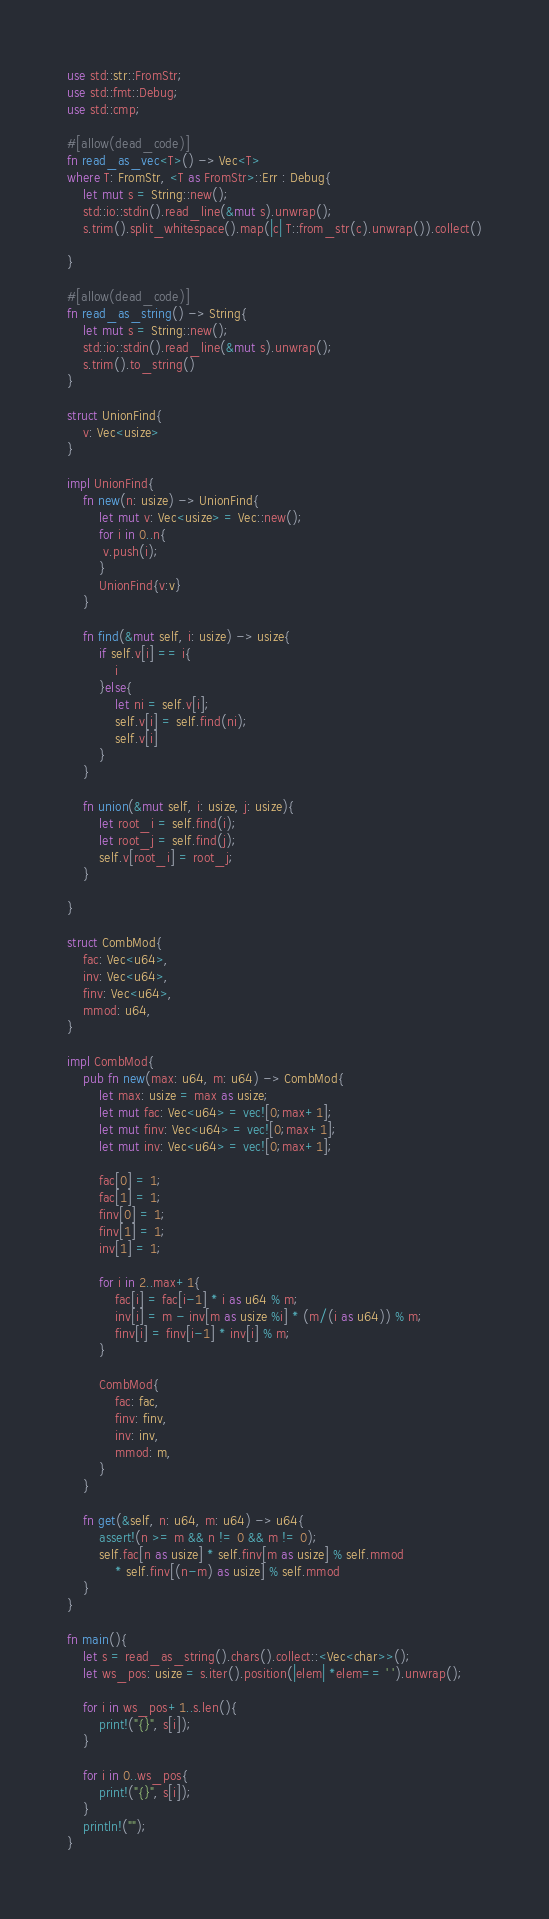<code> <loc_0><loc_0><loc_500><loc_500><_Rust_>use std::str::FromStr;
use std::fmt::Debug;
use std::cmp;

#[allow(dead_code)]
fn read_as_vec<T>() -> Vec<T>
where T: FromStr, <T as FromStr>::Err : Debug{
    let mut s = String::new();
    std::io::stdin().read_line(&mut s).unwrap();
    s.trim().split_whitespace().map(|c| T::from_str(c).unwrap()).collect()

}

#[allow(dead_code)]
fn read_as_string() -> String{
    let mut s = String::new();
    std::io::stdin().read_line(&mut s).unwrap();
    s.trim().to_string()
}

struct UnionFind{
    v: Vec<usize>
}

impl UnionFind{
    fn new(n: usize) -> UnionFind{
        let mut v: Vec<usize> = Vec::new();
        for i in 0..n{
         v.push(i);
        }
        UnionFind{v:v}
    }

    fn find(&mut self, i: usize) -> usize{
        if self.v[i] == i{
            i
        }else{
            let ni = self.v[i];
            self.v[i] = self.find(ni);
            self.v[i]
        }
    }

    fn union(&mut self, i: usize, j: usize){
        let root_i = self.find(i);
        let root_j = self.find(j);
        self.v[root_i] = root_j;
    }

}

struct CombMod{
    fac: Vec<u64>,
    inv: Vec<u64>,
    finv: Vec<u64>,
    mmod: u64,
}

impl CombMod{
    pub fn new(max: u64, m: u64) -> CombMod{
        let max: usize = max as usize;
        let mut fac: Vec<u64> = vec![0;max+1];
        let mut finv: Vec<u64> = vec![0;max+1];
        let mut inv: Vec<u64> = vec![0;max+1];

        fac[0] = 1;
        fac[1] = 1;
        finv[0] = 1;
        finv[1] = 1;
        inv[1] = 1;

        for i in 2..max+1{
            fac[i] = fac[i-1] * i as u64 % m;
            inv[i] = m - inv[m as usize %i] * (m/(i as u64)) % m;
            finv[i] = finv[i-1] * inv[i] % m;
        }

        CombMod{
            fac: fac,
            finv: finv,
            inv: inv,
            mmod: m,
        }
    }

    fn get(&self, n: u64, m: u64) -> u64{
        assert!(n >= m && n != 0 && m != 0);
        self.fac[n as usize] * self.finv[m as usize] % self.mmod
            * self.finv[(n-m) as usize] % self.mmod
    }
}

fn main(){
    let s = read_as_string().chars().collect::<Vec<char>>();
    let ws_pos: usize = s.iter().position(|elem| *elem== ' ').unwrap();

    for i in ws_pos+1..s.len(){
        print!("{}", s[i]);
    }

    for i in 0..ws_pos{
        print!("{}", s[i]);
    }
    println!("");
}
</code> 